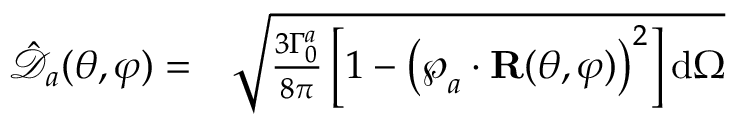<formula> <loc_0><loc_0><loc_500><loc_500>\begin{array} { r l } { \mathcal { \hat { \mathcal { D } } } _ { a } ( \theta , \varphi ) = } & \sqrt { \frac { 3 \Gamma _ { 0 } ^ { a } } { 8 \pi } \left [ 1 - \left ( \wp _ { a } \cdot R ( \theta , \varphi ) \right ) ^ { 2 } \right ] d \Omega } } \end{array}</formula> 